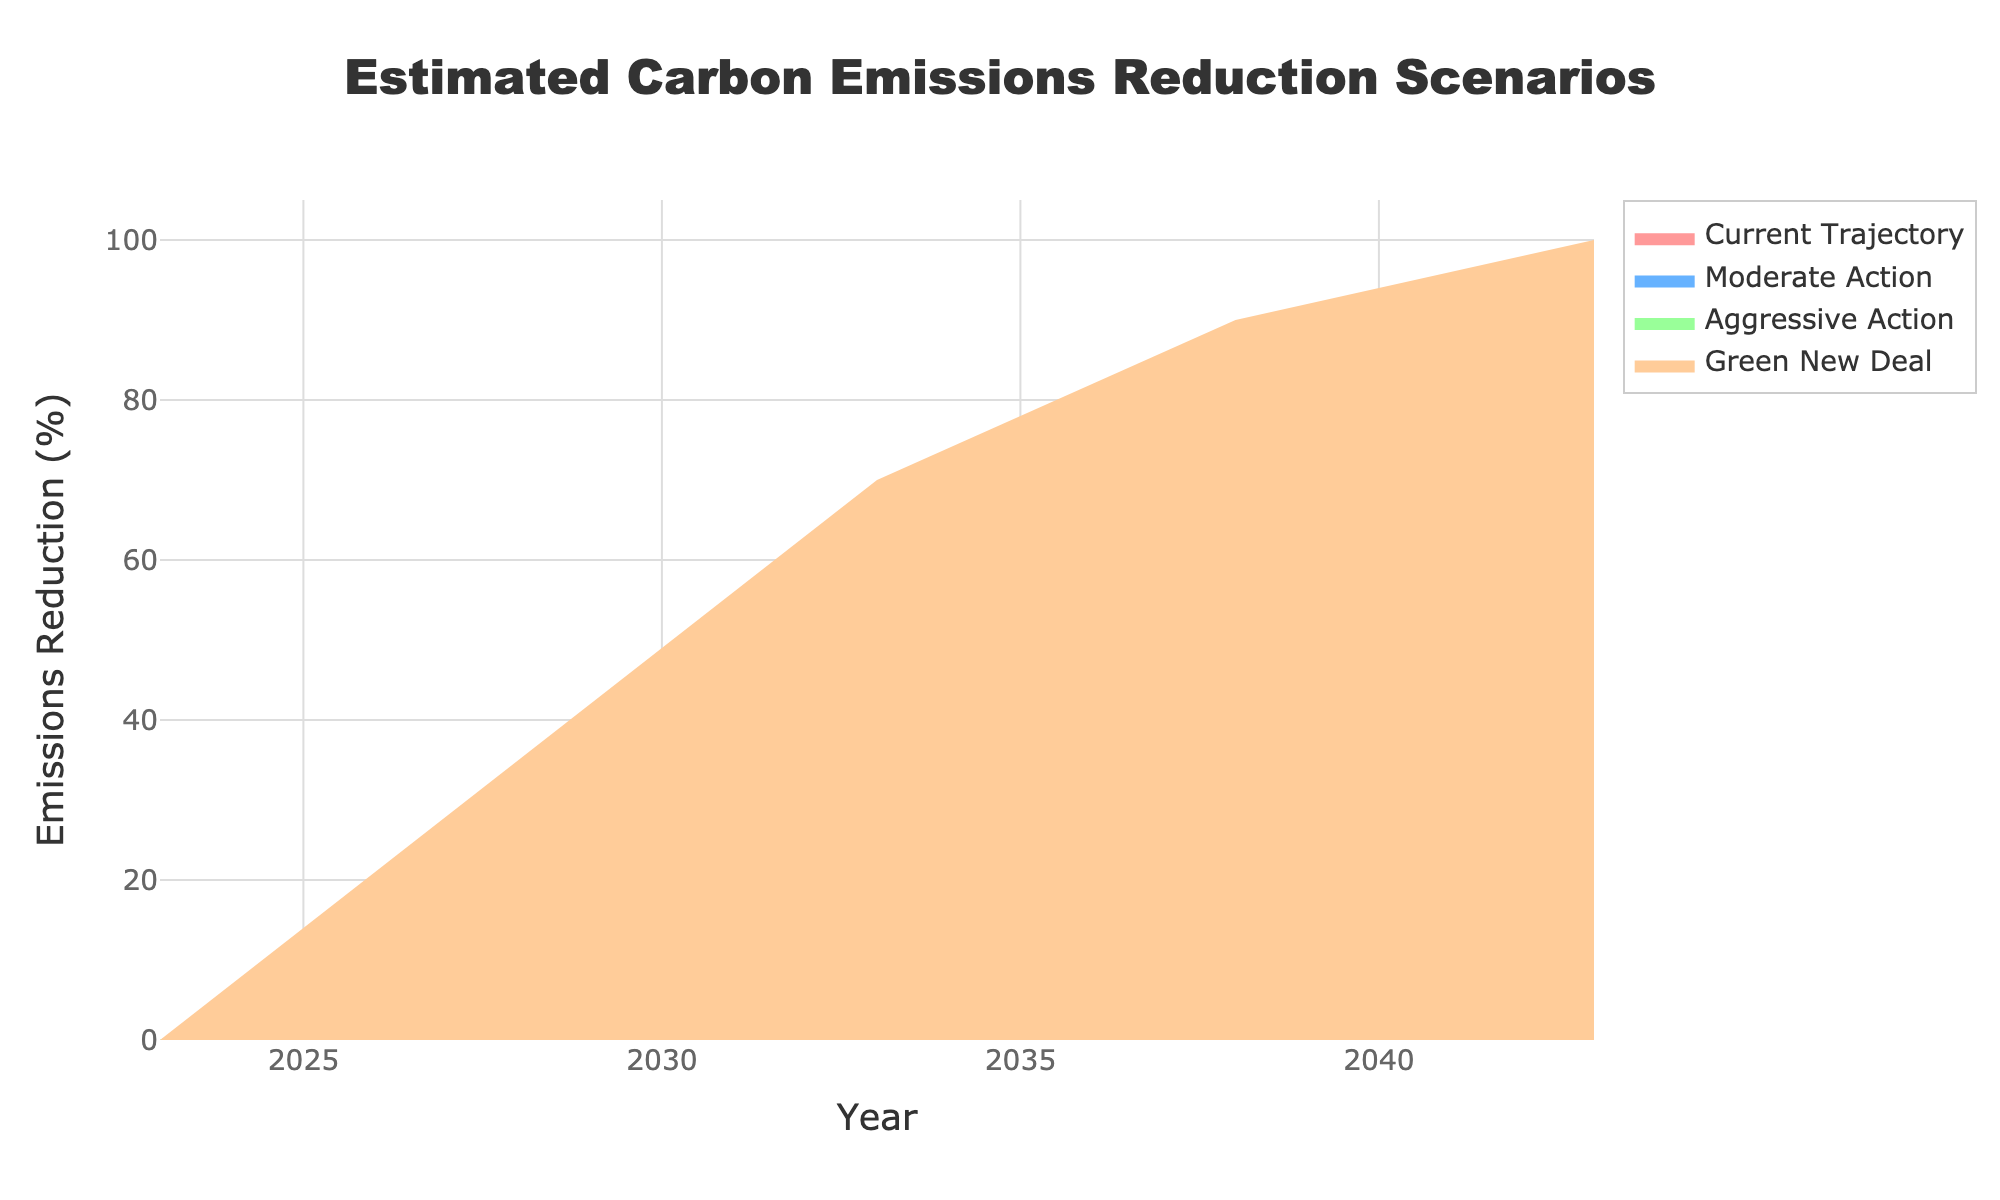What is the title of the chart? The title is prominently displayed at the top of the chart, it reads "Estimated Carbon Emissions Reduction Scenarios".
Answer: Estimated Carbon Emissions Reduction Scenarios What does the y-axis represent? The y-axis represents the "Emissions Reduction (%)" as indicated by the label on the y-axis.
Answer: Emissions Reduction (%) In what year do all scenarios start to diverge from each other? All scenarios start from the same point in 2023, but by referring to the plot, we can see that they diverge by 2028, with different projected reductions.
Answer: 2028 Which scenario predicts the highest emissions reduction by 2043? The Green New Deal scenario predicts the highest emissions reduction in 2043, reaching 100% as indicated in the fan chart.
Answer: Green New Deal How much greater is the emissions reduction in the Aggressive Action scenario compared to the Current Trajectory scenario in 2033? In 2033, Aggressive Action is 50% and Current Trajectory is 10%. The difference is 50% - 10% = 40%.
Answer: 40% Compare the emissions reductions projected in the Moderate Action scenario to the Aggressive Action scenario in 2038. In 2038, Moderate Action is predicted to achieve a 45% reduction, while Aggressive Action is predicted to achieve a 75% reduction. The Moderate Action reduction is 30% less than Aggressive Action reduction (75% - 45%).
Answer: 30% What can be inferred about the relationship between the policy impact and emissions reduction over the time span according to the chart? Based on the chart, the more aggressive the policy (e.g., moving from Current Trajectory to Green New Deal), the greater the emissions reduction over time, indicating a strong positive correlation between policy aggressiveness and emissions reduction.
Answer: Positive correlation between policy aggressiveness and emissions reduction By how much does the emissions reduction increase in the Moderate Action scenario from 2028 to 2043? The emissions reduction in the Moderate Action scenario is 15% in 2028 and 60% in 2043. The increase is 60% - 15% = 45%.
Answer: 45% What are the final reductions projected for each scenario in 2043? The projections for 2043 are present in the fan chart: Current Trajectory 20%, Moderate Action 60%, Aggressive Action 90%, and Green New Deal 100%.
Answer: Current Trajectory 20%, Moderate Action 60%, Aggressive Action 90%, Green New Deal 100% Which scenario shows the least improvement by 2028, and what is the predicted reduction percentage? The Current Trajectory scenario shows the least improvement by 2028 with a reduction percentage of 5%.
Answer: Current Trajectory, 5% 